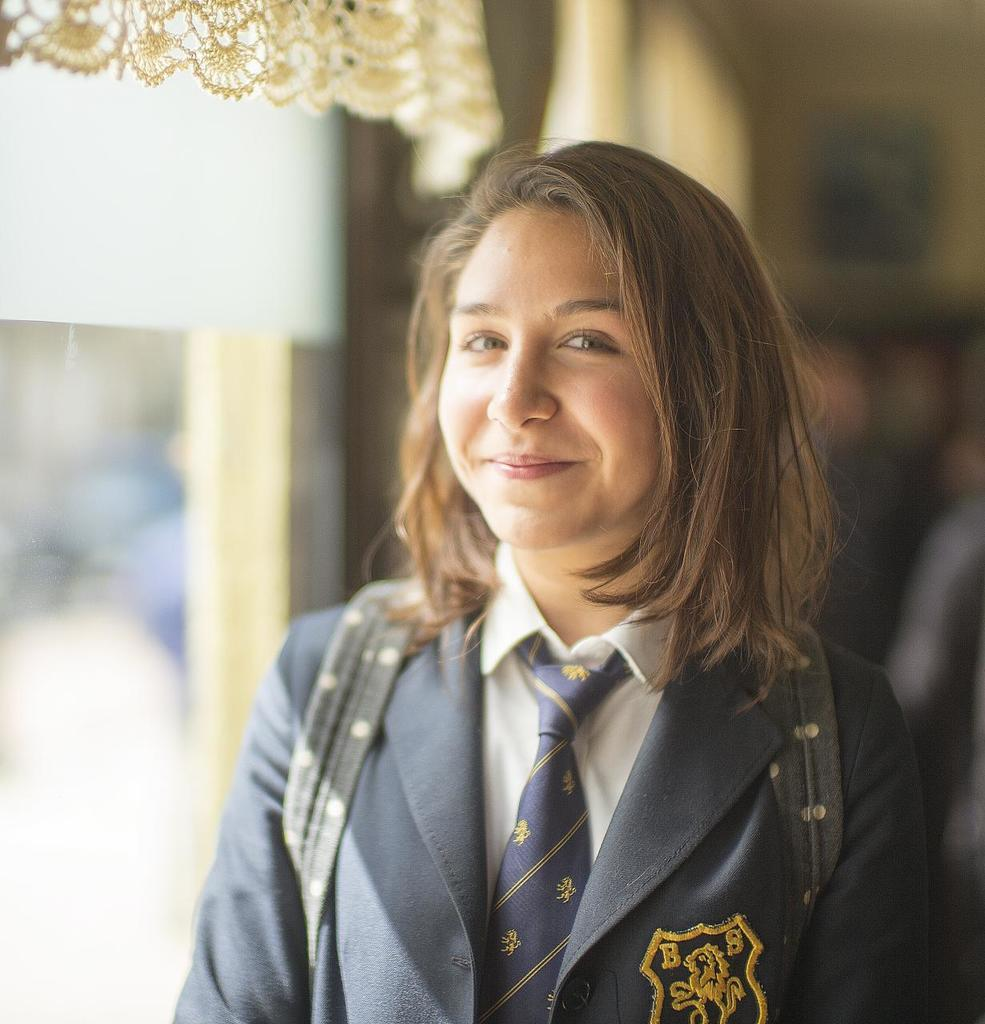Who is the main subject in the image? There is a woman in the image. What is the woman wearing? The woman is wearing a blue coat and tie. What expression does the woman have? The woman is smiling. What can be seen on the left side of the image? There is a glass on the left side of the image. How would you describe the background of the image? The background of the image is blurred. What news is the woman delivering in the image? There is no indication in the image that the woman is delivering any news. What type of lunch is the woman eating in the image? There is no lunch present in the image; it only shows a woman wearing a blue coat and tie, smiling, with a glass on the left side of the image and a blurred background. 